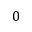<formula> <loc_0><loc_0><loc_500><loc_500>0</formula> 